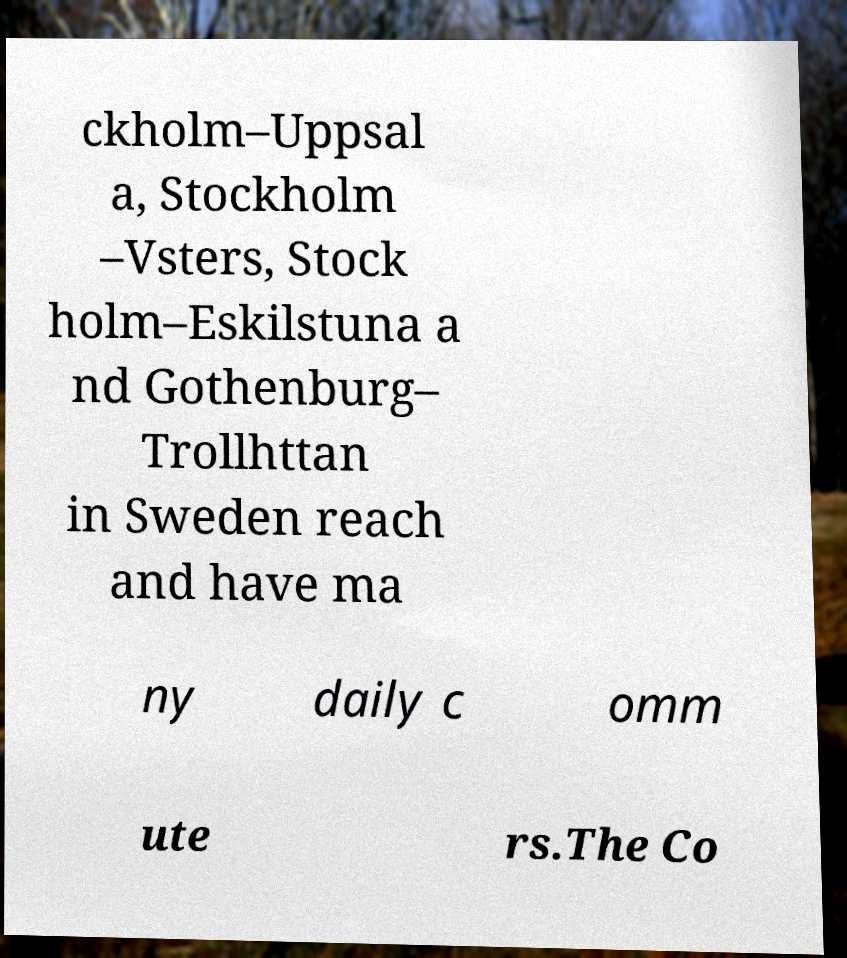There's text embedded in this image that I need extracted. Can you transcribe it verbatim? ckholm–Uppsal a, Stockholm –Vsters, Stock holm–Eskilstuna a nd Gothenburg– Trollhttan in Sweden reach and have ma ny daily c omm ute rs.The Co 